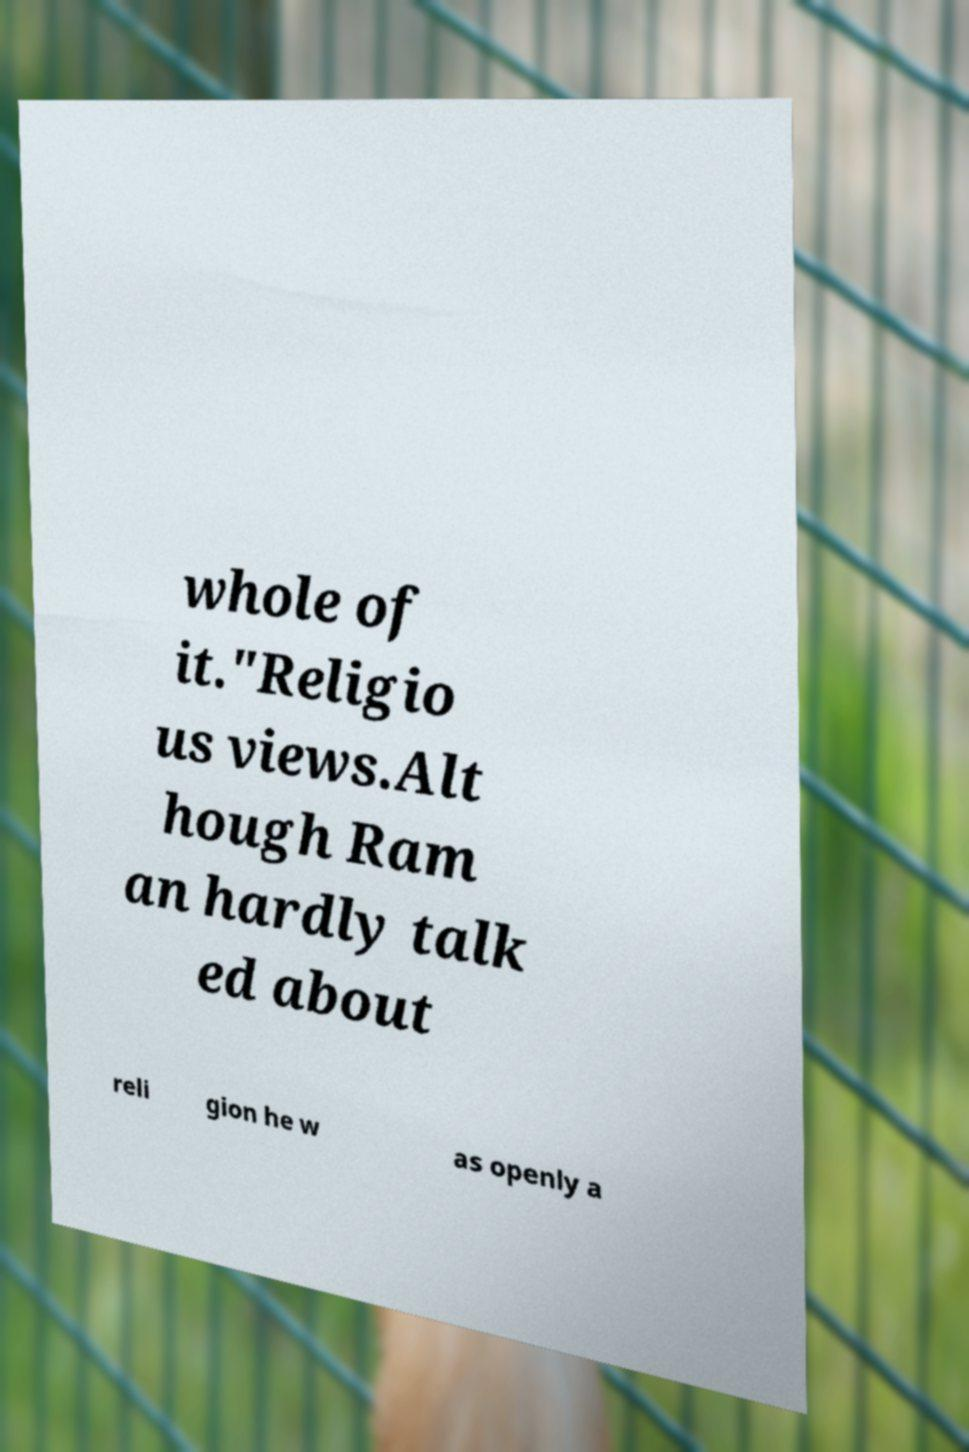Could you extract and type out the text from this image? whole of it."Religio us views.Alt hough Ram an hardly talk ed about reli gion he w as openly a 